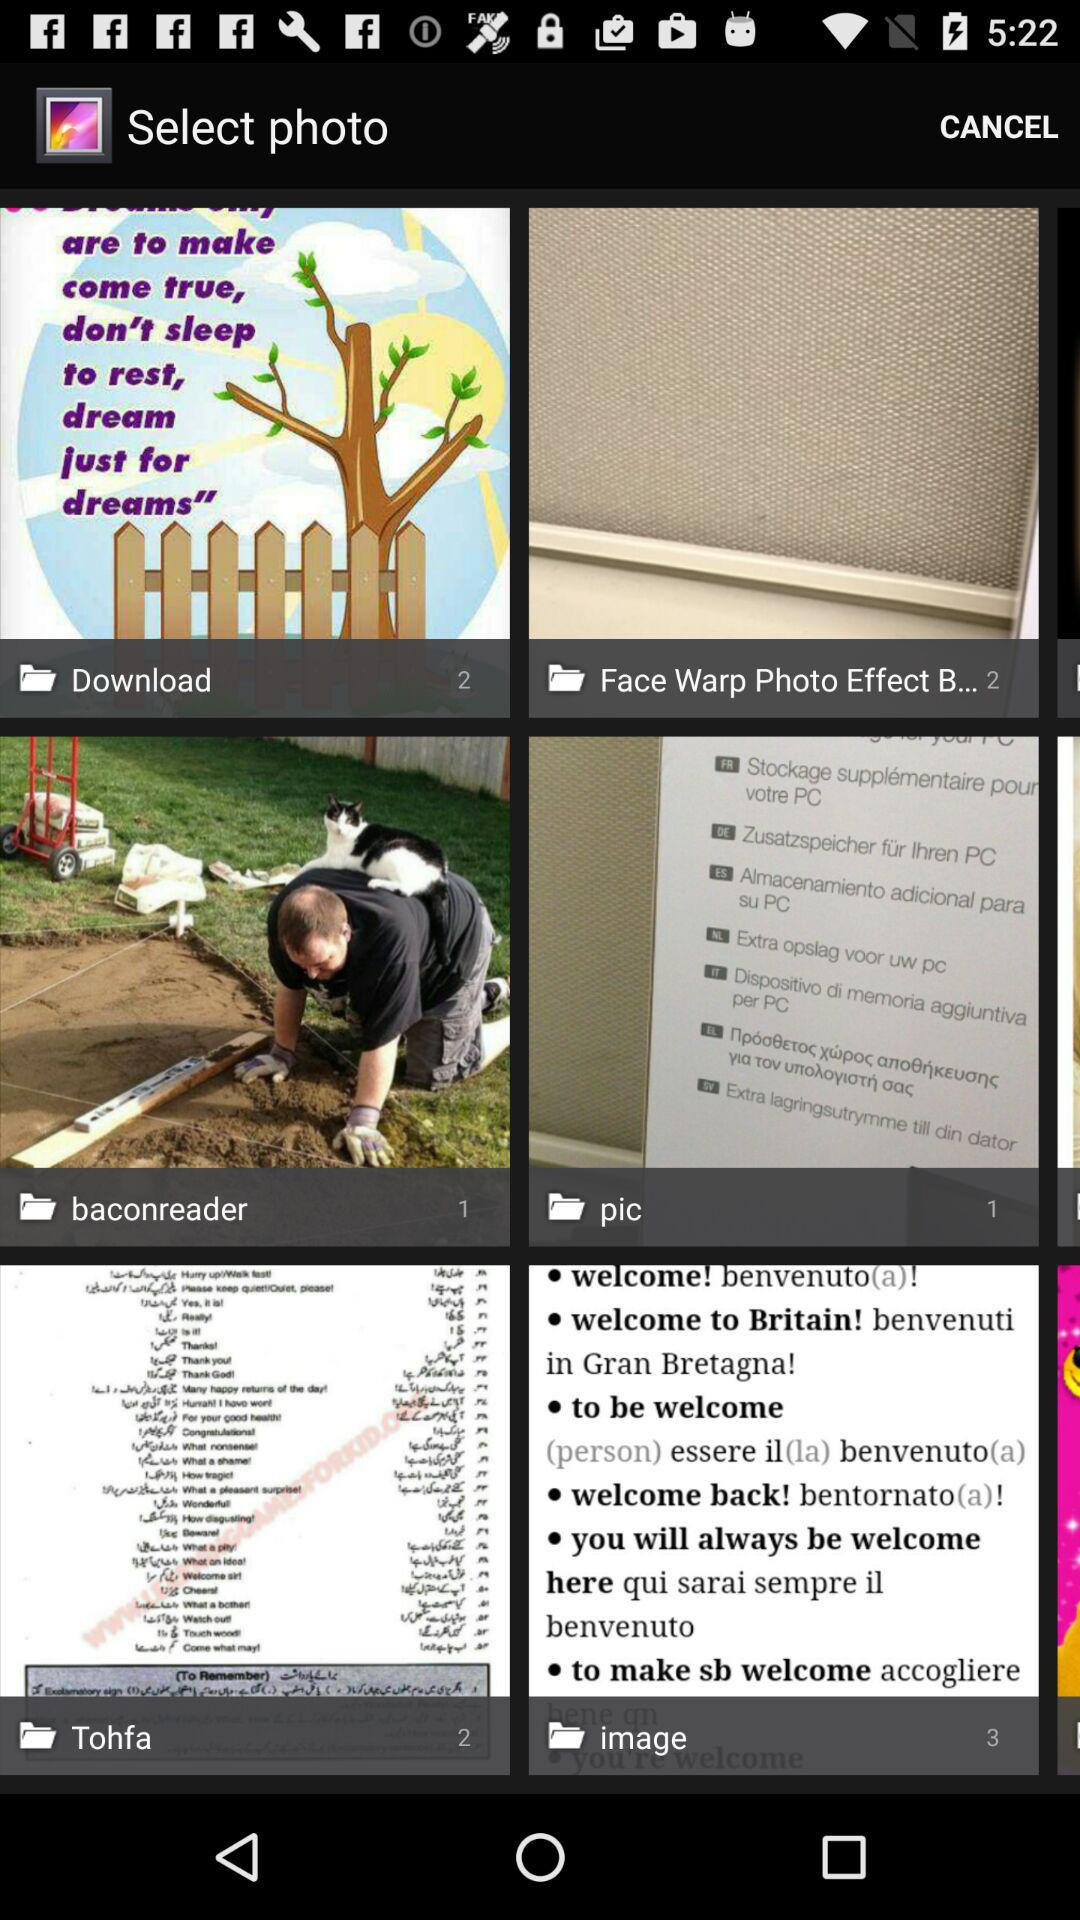How many photos are present in the "image"? There are 3 photos present in the "image". 